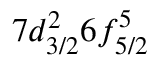<formula> <loc_0><loc_0><loc_500><loc_500>7 d _ { 3 / 2 } ^ { 2 } 6 f _ { 5 / 2 } ^ { 5 }</formula> 